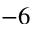<formula> <loc_0><loc_0><loc_500><loc_500>^ { - 6 }</formula> 